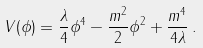Convert formula to latex. <formula><loc_0><loc_0><loc_500><loc_500>V ( \phi ) = \frac { \lambda } { 4 } \phi ^ { 4 } - \frac { m ^ { 2 } } { 2 } \phi ^ { 2 } + \frac { m ^ { 4 } } { 4 \lambda } \, .</formula> 